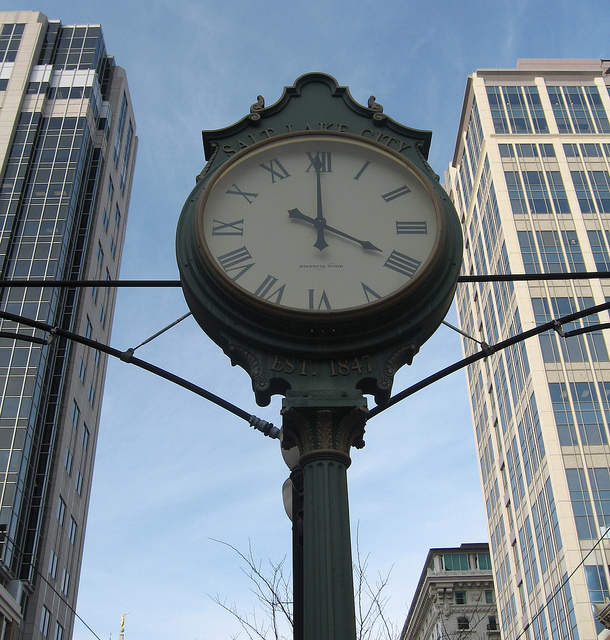Please transcribe the text information in this image. XII XI X XI VIII CITY SALT III II I III A VI EST. 